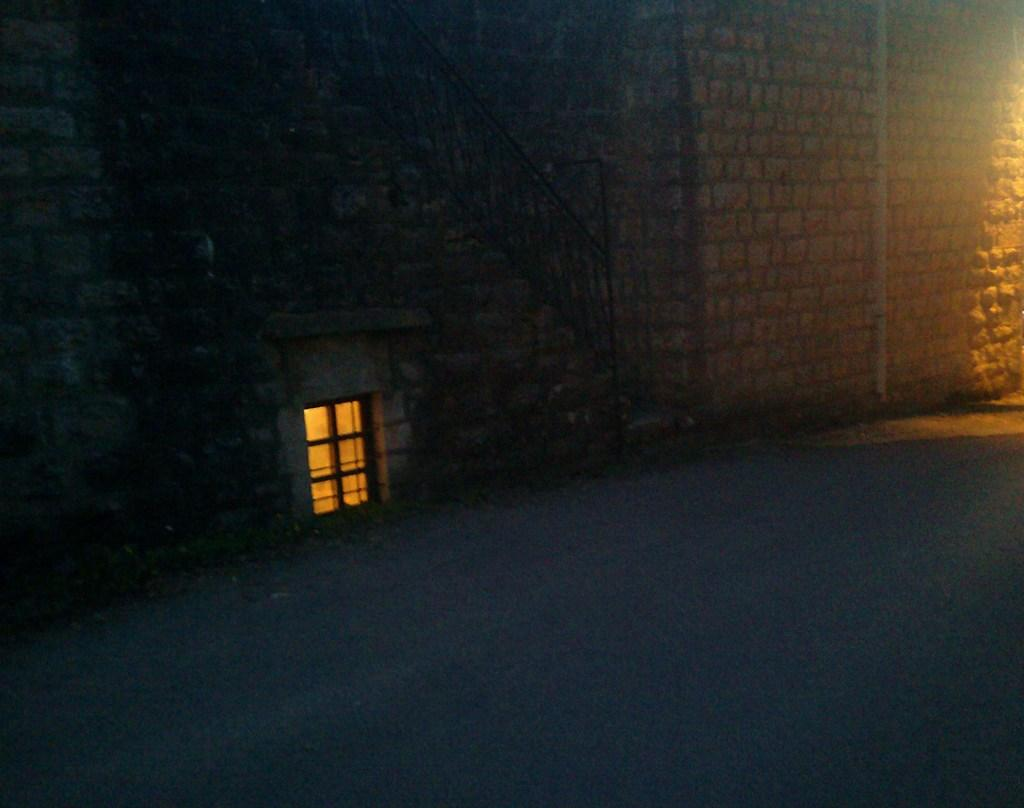What type of structure can be seen in the image? There is a brick wall present in the image. What architectural feature is visible in the image? There is a staircase in the image. What type of window is present in the image? There is a glass window in the image. What color is the spot on the staircase in the image? There is no spot mentioned or visible on the staircase in the image. What day of the week is depicted in the image? The image does not depict a specific day of the week; it only shows a brick wall, a staircase, and a glass window. 